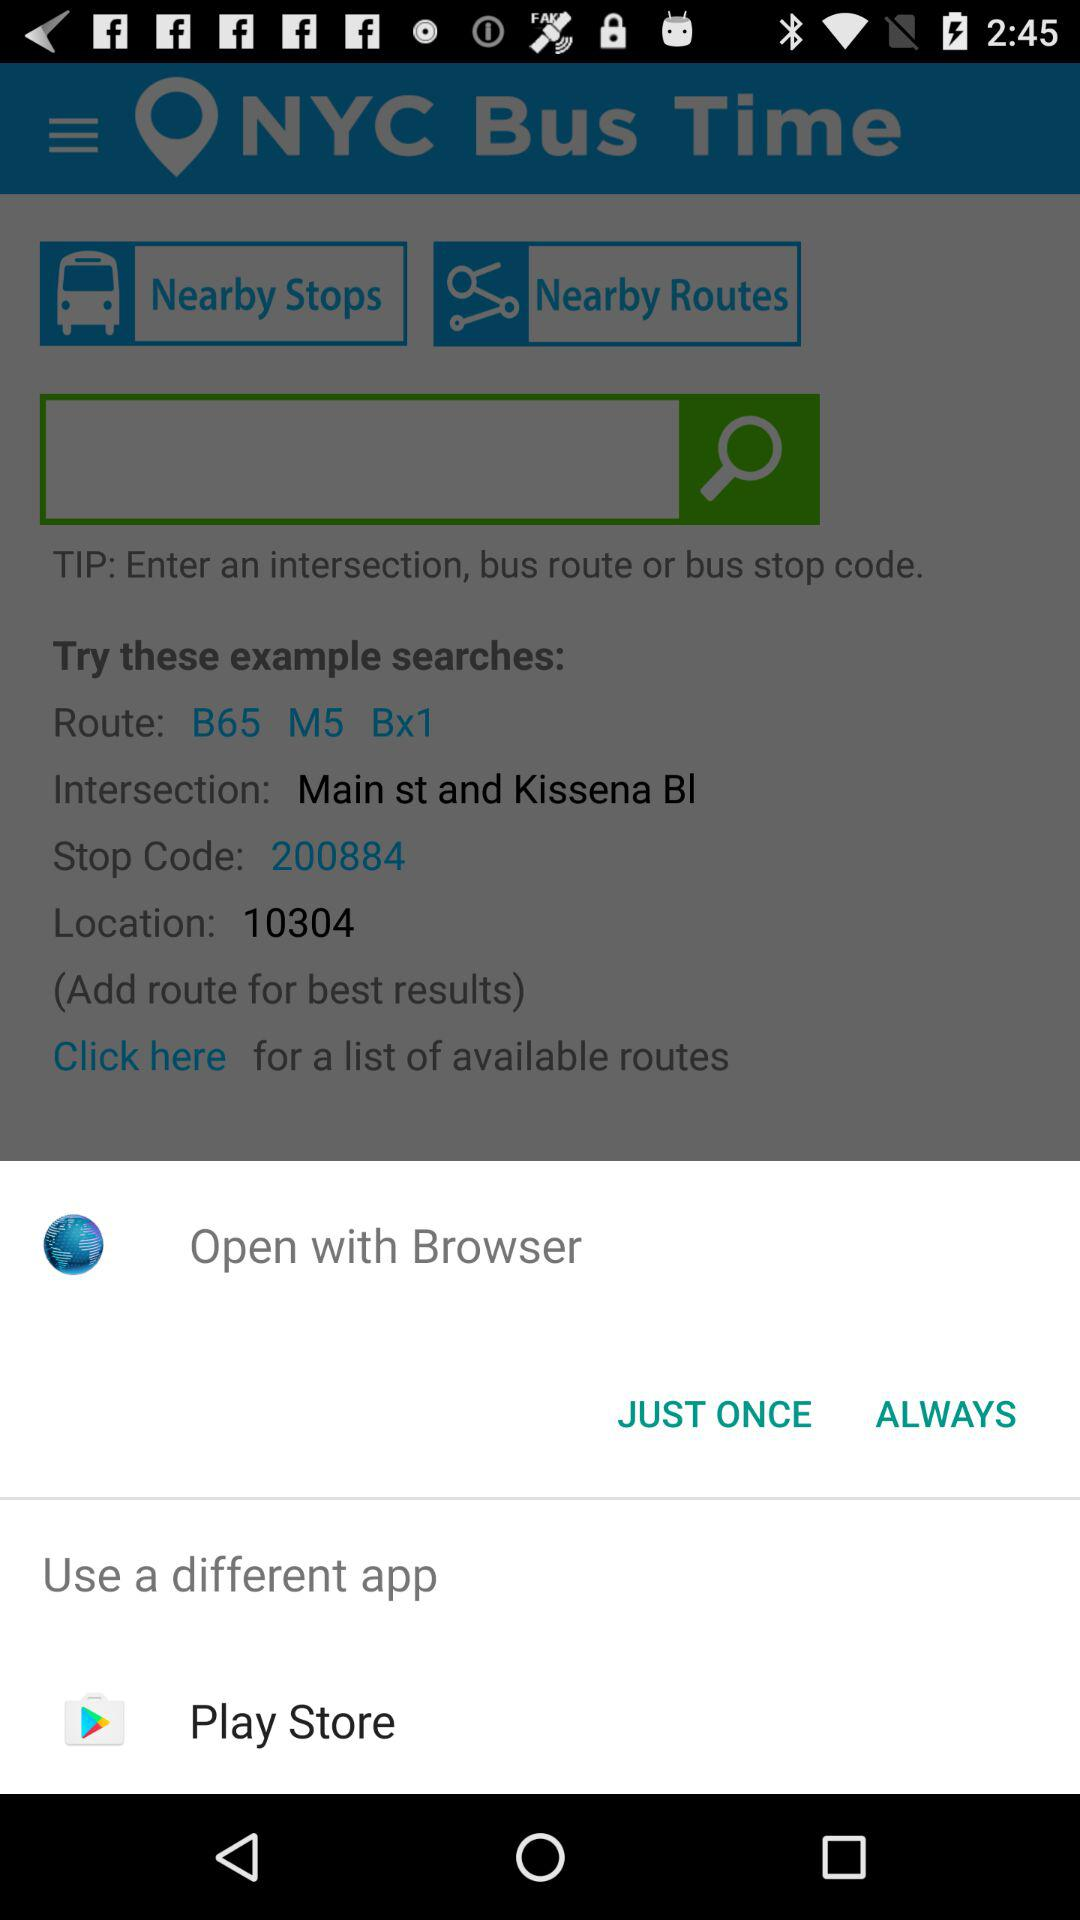What different applications can we use to open the content? You can use "Play Store" application to open the content. 